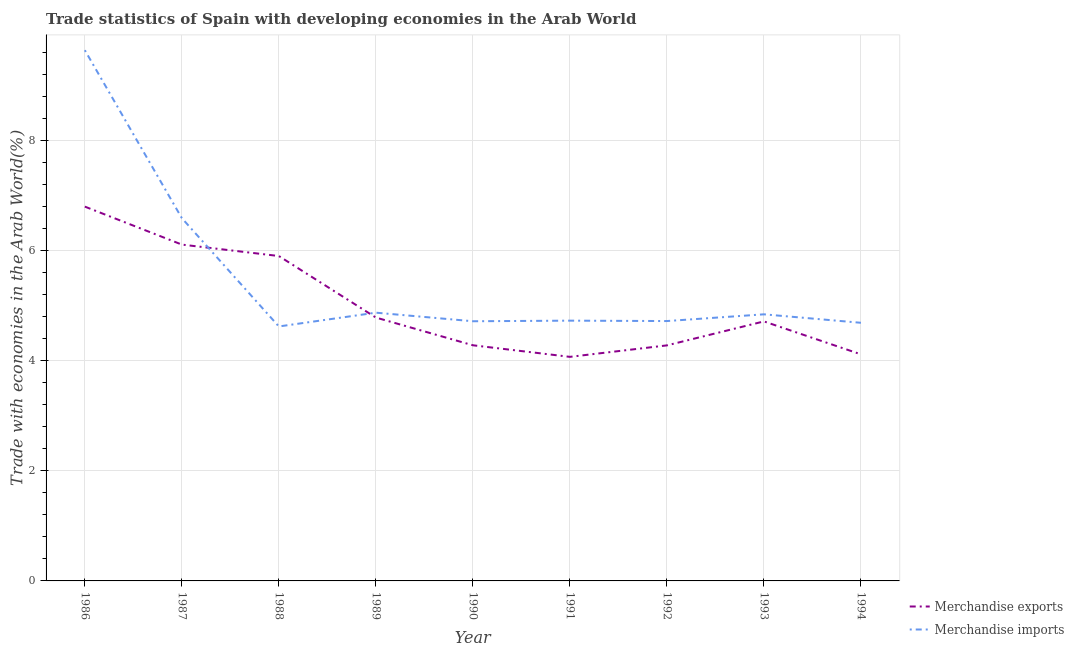How many different coloured lines are there?
Offer a terse response. 2. Does the line corresponding to merchandise exports intersect with the line corresponding to merchandise imports?
Ensure brevity in your answer.  Yes. Is the number of lines equal to the number of legend labels?
Provide a short and direct response. Yes. What is the merchandise imports in 1986?
Your answer should be compact. 9.64. Across all years, what is the maximum merchandise exports?
Offer a very short reply. 6.8. Across all years, what is the minimum merchandise imports?
Provide a succinct answer. 4.62. What is the total merchandise imports in the graph?
Your response must be concise. 49.4. What is the difference between the merchandise exports in 1989 and that in 1992?
Give a very brief answer. 0.51. What is the difference between the merchandise imports in 1993 and the merchandise exports in 1994?
Your answer should be compact. 0.73. What is the average merchandise imports per year?
Make the answer very short. 5.49. In the year 1986, what is the difference between the merchandise imports and merchandise exports?
Offer a very short reply. 2.84. In how many years, is the merchandise exports greater than 2 %?
Your response must be concise. 9. What is the ratio of the merchandise exports in 1988 to that in 1990?
Offer a very short reply. 1.38. Is the merchandise exports in 1992 less than that in 1993?
Offer a terse response. Yes. What is the difference between the highest and the second highest merchandise exports?
Keep it short and to the point. 0.69. What is the difference between the highest and the lowest merchandise imports?
Offer a terse response. 5.02. In how many years, is the merchandise exports greater than the average merchandise exports taken over all years?
Your response must be concise. 3. Is the merchandise imports strictly greater than the merchandise exports over the years?
Your response must be concise. No. Is the merchandise imports strictly less than the merchandise exports over the years?
Provide a short and direct response. No. How many years are there in the graph?
Make the answer very short. 9. Are the values on the major ticks of Y-axis written in scientific E-notation?
Ensure brevity in your answer.  No. Where does the legend appear in the graph?
Keep it short and to the point. Bottom right. What is the title of the graph?
Keep it short and to the point. Trade statistics of Spain with developing economies in the Arab World. What is the label or title of the X-axis?
Your answer should be compact. Year. What is the label or title of the Y-axis?
Provide a short and direct response. Trade with economies in the Arab World(%). What is the Trade with economies in the Arab World(%) of Merchandise exports in 1986?
Your response must be concise. 6.8. What is the Trade with economies in the Arab World(%) of Merchandise imports in 1986?
Your answer should be very brief. 9.64. What is the Trade with economies in the Arab World(%) of Merchandise exports in 1987?
Keep it short and to the point. 6.11. What is the Trade with economies in the Arab World(%) in Merchandise imports in 1987?
Offer a very short reply. 6.59. What is the Trade with economies in the Arab World(%) in Merchandise exports in 1988?
Make the answer very short. 5.9. What is the Trade with economies in the Arab World(%) of Merchandise imports in 1988?
Your answer should be very brief. 4.62. What is the Trade with economies in the Arab World(%) in Merchandise exports in 1989?
Ensure brevity in your answer.  4.78. What is the Trade with economies in the Arab World(%) in Merchandise imports in 1989?
Your response must be concise. 4.87. What is the Trade with economies in the Arab World(%) in Merchandise exports in 1990?
Provide a succinct answer. 4.28. What is the Trade with economies in the Arab World(%) of Merchandise imports in 1990?
Keep it short and to the point. 4.72. What is the Trade with economies in the Arab World(%) of Merchandise exports in 1991?
Offer a terse response. 4.07. What is the Trade with economies in the Arab World(%) in Merchandise imports in 1991?
Offer a very short reply. 4.73. What is the Trade with economies in the Arab World(%) of Merchandise exports in 1992?
Offer a very short reply. 4.28. What is the Trade with economies in the Arab World(%) in Merchandise imports in 1992?
Your response must be concise. 4.72. What is the Trade with economies in the Arab World(%) of Merchandise exports in 1993?
Make the answer very short. 4.71. What is the Trade with economies in the Arab World(%) in Merchandise imports in 1993?
Ensure brevity in your answer.  4.84. What is the Trade with economies in the Arab World(%) of Merchandise exports in 1994?
Offer a terse response. 4.11. What is the Trade with economies in the Arab World(%) in Merchandise imports in 1994?
Offer a very short reply. 4.69. Across all years, what is the maximum Trade with economies in the Arab World(%) of Merchandise exports?
Your answer should be compact. 6.8. Across all years, what is the maximum Trade with economies in the Arab World(%) of Merchandise imports?
Ensure brevity in your answer.  9.64. Across all years, what is the minimum Trade with economies in the Arab World(%) of Merchandise exports?
Make the answer very short. 4.07. Across all years, what is the minimum Trade with economies in the Arab World(%) of Merchandise imports?
Offer a very short reply. 4.62. What is the total Trade with economies in the Arab World(%) in Merchandise exports in the graph?
Keep it short and to the point. 45.04. What is the total Trade with economies in the Arab World(%) of Merchandise imports in the graph?
Offer a terse response. 49.4. What is the difference between the Trade with economies in the Arab World(%) of Merchandise exports in 1986 and that in 1987?
Keep it short and to the point. 0.69. What is the difference between the Trade with economies in the Arab World(%) in Merchandise imports in 1986 and that in 1987?
Offer a very short reply. 3.05. What is the difference between the Trade with economies in the Arab World(%) in Merchandise exports in 1986 and that in 1988?
Your answer should be compact. 0.9. What is the difference between the Trade with economies in the Arab World(%) of Merchandise imports in 1986 and that in 1988?
Ensure brevity in your answer.  5.02. What is the difference between the Trade with economies in the Arab World(%) of Merchandise exports in 1986 and that in 1989?
Give a very brief answer. 2.01. What is the difference between the Trade with economies in the Arab World(%) of Merchandise imports in 1986 and that in 1989?
Offer a terse response. 4.77. What is the difference between the Trade with economies in the Arab World(%) in Merchandise exports in 1986 and that in 1990?
Ensure brevity in your answer.  2.52. What is the difference between the Trade with economies in the Arab World(%) of Merchandise imports in 1986 and that in 1990?
Make the answer very short. 4.92. What is the difference between the Trade with economies in the Arab World(%) in Merchandise exports in 1986 and that in 1991?
Provide a short and direct response. 2.73. What is the difference between the Trade with economies in the Arab World(%) of Merchandise imports in 1986 and that in 1991?
Provide a short and direct response. 4.91. What is the difference between the Trade with economies in the Arab World(%) of Merchandise exports in 1986 and that in 1992?
Your response must be concise. 2.52. What is the difference between the Trade with economies in the Arab World(%) of Merchandise imports in 1986 and that in 1992?
Offer a terse response. 4.92. What is the difference between the Trade with economies in the Arab World(%) of Merchandise exports in 1986 and that in 1993?
Provide a short and direct response. 2.08. What is the difference between the Trade with economies in the Arab World(%) in Merchandise imports in 1986 and that in 1993?
Keep it short and to the point. 4.8. What is the difference between the Trade with economies in the Arab World(%) of Merchandise exports in 1986 and that in 1994?
Make the answer very short. 2.68. What is the difference between the Trade with economies in the Arab World(%) in Merchandise imports in 1986 and that in 1994?
Provide a short and direct response. 4.95. What is the difference between the Trade with economies in the Arab World(%) of Merchandise exports in 1987 and that in 1988?
Your answer should be very brief. 0.21. What is the difference between the Trade with economies in the Arab World(%) in Merchandise imports in 1987 and that in 1988?
Offer a very short reply. 1.97. What is the difference between the Trade with economies in the Arab World(%) of Merchandise exports in 1987 and that in 1989?
Offer a terse response. 1.32. What is the difference between the Trade with economies in the Arab World(%) in Merchandise imports in 1987 and that in 1989?
Offer a terse response. 1.72. What is the difference between the Trade with economies in the Arab World(%) in Merchandise exports in 1987 and that in 1990?
Offer a terse response. 1.83. What is the difference between the Trade with economies in the Arab World(%) in Merchandise imports in 1987 and that in 1990?
Your response must be concise. 1.87. What is the difference between the Trade with economies in the Arab World(%) in Merchandise exports in 1987 and that in 1991?
Ensure brevity in your answer.  2.04. What is the difference between the Trade with economies in the Arab World(%) in Merchandise imports in 1987 and that in 1991?
Your answer should be compact. 1.86. What is the difference between the Trade with economies in the Arab World(%) in Merchandise exports in 1987 and that in 1992?
Provide a succinct answer. 1.83. What is the difference between the Trade with economies in the Arab World(%) in Merchandise imports in 1987 and that in 1992?
Your response must be concise. 1.87. What is the difference between the Trade with economies in the Arab World(%) of Merchandise exports in 1987 and that in 1993?
Keep it short and to the point. 1.39. What is the difference between the Trade with economies in the Arab World(%) in Merchandise imports in 1987 and that in 1993?
Ensure brevity in your answer.  1.75. What is the difference between the Trade with economies in the Arab World(%) in Merchandise exports in 1987 and that in 1994?
Provide a short and direct response. 1.99. What is the difference between the Trade with economies in the Arab World(%) of Merchandise exports in 1988 and that in 1989?
Provide a short and direct response. 1.12. What is the difference between the Trade with economies in the Arab World(%) of Merchandise imports in 1988 and that in 1989?
Your answer should be very brief. -0.25. What is the difference between the Trade with economies in the Arab World(%) in Merchandise exports in 1988 and that in 1990?
Ensure brevity in your answer.  1.62. What is the difference between the Trade with economies in the Arab World(%) in Merchandise imports in 1988 and that in 1990?
Keep it short and to the point. -0.09. What is the difference between the Trade with economies in the Arab World(%) in Merchandise exports in 1988 and that in 1991?
Provide a succinct answer. 1.83. What is the difference between the Trade with economies in the Arab World(%) in Merchandise imports in 1988 and that in 1991?
Give a very brief answer. -0.11. What is the difference between the Trade with economies in the Arab World(%) in Merchandise exports in 1988 and that in 1992?
Provide a short and direct response. 1.62. What is the difference between the Trade with economies in the Arab World(%) of Merchandise imports in 1988 and that in 1992?
Ensure brevity in your answer.  -0.1. What is the difference between the Trade with economies in the Arab World(%) in Merchandise exports in 1988 and that in 1993?
Give a very brief answer. 1.19. What is the difference between the Trade with economies in the Arab World(%) in Merchandise imports in 1988 and that in 1993?
Your response must be concise. -0.22. What is the difference between the Trade with economies in the Arab World(%) of Merchandise exports in 1988 and that in 1994?
Your answer should be compact. 1.79. What is the difference between the Trade with economies in the Arab World(%) in Merchandise imports in 1988 and that in 1994?
Provide a succinct answer. -0.07. What is the difference between the Trade with economies in the Arab World(%) of Merchandise exports in 1989 and that in 1990?
Your answer should be very brief. 0.5. What is the difference between the Trade with economies in the Arab World(%) of Merchandise imports in 1989 and that in 1990?
Provide a succinct answer. 0.16. What is the difference between the Trade with economies in the Arab World(%) of Merchandise exports in 1989 and that in 1991?
Ensure brevity in your answer.  0.71. What is the difference between the Trade with economies in the Arab World(%) in Merchandise imports in 1989 and that in 1991?
Ensure brevity in your answer.  0.14. What is the difference between the Trade with economies in the Arab World(%) of Merchandise exports in 1989 and that in 1992?
Your answer should be compact. 0.51. What is the difference between the Trade with economies in the Arab World(%) of Merchandise imports in 1989 and that in 1992?
Provide a short and direct response. 0.15. What is the difference between the Trade with economies in the Arab World(%) in Merchandise exports in 1989 and that in 1993?
Your answer should be very brief. 0.07. What is the difference between the Trade with economies in the Arab World(%) in Merchandise exports in 1989 and that in 1994?
Offer a very short reply. 0.67. What is the difference between the Trade with economies in the Arab World(%) of Merchandise imports in 1989 and that in 1994?
Your answer should be very brief. 0.18. What is the difference between the Trade with economies in the Arab World(%) of Merchandise exports in 1990 and that in 1991?
Keep it short and to the point. 0.21. What is the difference between the Trade with economies in the Arab World(%) of Merchandise imports in 1990 and that in 1991?
Provide a short and direct response. -0.01. What is the difference between the Trade with economies in the Arab World(%) in Merchandise exports in 1990 and that in 1992?
Provide a short and direct response. 0. What is the difference between the Trade with economies in the Arab World(%) of Merchandise imports in 1990 and that in 1992?
Provide a short and direct response. -0. What is the difference between the Trade with economies in the Arab World(%) of Merchandise exports in 1990 and that in 1993?
Provide a short and direct response. -0.43. What is the difference between the Trade with economies in the Arab World(%) of Merchandise imports in 1990 and that in 1993?
Keep it short and to the point. -0.13. What is the difference between the Trade with economies in the Arab World(%) in Merchandise exports in 1990 and that in 1994?
Give a very brief answer. 0.16. What is the difference between the Trade with economies in the Arab World(%) in Merchandise imports in 1990 and that in 1994?
Your answer should be compact. 0.03. What is the difference between the Trade with economies in the Arab World(%) of Merchandise exports in 1991 and that in 1992?
Offer a very short reply. -0.21. What is the difference between the Trade with economies in the Arab World(%) of Merchandise imports in 1991 and that in 1992?
Provide a short and direct response. 0.01. What is the difference between the Trade with economies in the Arab World(%) of Merchandise exports in 1991 and that in 1993?
Offer a terse response. -0.64. What is the difference between the Trade with economies in the Arab World(%) of Merchandise imports in 1991 and that in 1993?
Provide a short and direct response. -0.11. What is the difference between the Trade with economies in the Arab World(%) in Merchandise exports in 1991 and that in 1994?
Provide a succinct answer. -0.05. What is the difference between the Trade with economies in the Arab World(%) of Merchandise imports in 1991 and that in 1994?
Keep it short and to the point. 0.04. What is the difference between the Trade with economies in the Arab World(%) in Merchandise exports in 1992 and that in 1993?
Provide a short and direct response. -0.44. What is the difference between the Trade with economies in the Arab World(%) of Merchandise imports in 1992 and that in 1993?
Offer a very short reply. -0.12. What is the difference between the Trade with economies in the Arab World(%) of Merchandise exports in 1992 and that in 1994?
Keep it short and to the point. 0.16. What is the difference between the Trade with economies in the Arab World(%) in Merchandise imports in 1992 and that in 1994?
Provide a succinct answer. 0.03. What is the difference between the Trade with economies in the Arab World(%) in Merchandise exports in 1993 and that in 1994?
Offer a terse response. 0.6. What is the difference between the Trade with economies in the Arab World(%) in Merchandise imports in 1993 and that in 1994?
Provide a succinct answer. 0.15. What is the difference between the Trade with economies in the Arab World(%) of Merchandise exports in 1986 and the Trade with economies in the Arab World(%) of Merchandise imports in 1987?
Offer a terse response. 0.21. What is the difference between the Trade with economies in the Arab World(%) of Merchandise exports in 1986 and the Trade with economies in the Arab World(%) of Merchandise imports in 1988?
Keep it short and to the point. 2.18. What is the difference between the Trade with economies in the Arab World(%) of Merchandise exports in 1986 and the Trade with economies in the Arab World(%) of Merchandise imports in 1989?
Make the answer very short. 1.93. What is the difference between the Trade with economies in the Arab World(%) in Merchandise exports in 1986 and the Trade with economies in the Arab World(%) in Merchandise imports in 1990?
Give a very brief answer. 2.08. What is the difference between the Trade with economies in the Arab World(%) of Merchandise exports in 1986 and the Trade with economies in the Arab World(%) of Merchandise imports in 1991?
Ensure brevity in your answer.  2.07. What is the difference between the Trade with economies in the Arab World(%) in Merchandise exports in 1986 and the Trade with economies in the Arab World(%) in Merchandise imports in 1992?
Provide a succinct answer. 2.08. What is the difference between the Trade with economies in the Arab World(%) of Merchandise exports in 1986 and the Trade with economies in the Arab World(%) of Merchandise imports in 1993?
Make the answer very short. 1.96. What is the difference between the Trade with economies in the Arab World(%) in Merchandise exports in 1986 and the Trade with economies in the Arab World(%) in Merchandise imports in 1994?
Provide a succinct answer. 2.11. What is the difference between the Trade with economies in the Arab World(%) in Merchandise exports in 1987 and the Trade with economies in the Arab World(%) in Merchandise imports in 1988?
Your answer should be very brief. 1.49. What is the difference between the Trade with economies in the Arab World(%) in Merchandise exports in 1987 and the Trade with economies in the Arab World(%) in Merchandise imports in 1989?
Provide a short and direct response. 1.24. What is the difference between the Trade with economies in the Arab World(%) of Merchandise exports in 1987 and the Trade with economies in the Arab World(%) of Merchandise imports in 1990?
Your answer should be very brief. 1.39. What is the difference between the Trade with economies in the Arab World(%) of Merchandise exports in 1987 and the Trade with economies in the Arab World(%) of Merchandise imports in 1991?
Offer a terse response. 1.38. What is the difference between the Trade with economies in the Arab World(%) of Merchandise exports in 1987 and the Trade with economies in the Arab World(%) of Merchandise imports in 1992?
Your answer should be compact. 1.39. What is the difference between the Trade with economies in the Arab World(%) of Merchandise exports in 1987 and the Trade with economies in the Arab World(%) of Merchandise imports in 1993?
Provide a short and direct response. 1.27. What is the difference between the Trade with economies in the Arab World(%) of Merchandise exports in 1987 and the Trade with economies in the Arab World(%) of Merchandise imports in 1994?
Offer a terse response. 1.42. What is the difference between the Trade with economies in the Arab World(%) in Merchandise exports in 1988 and the Trade with economies in the Arab World(%) in Merchandise imports in 1989?
Make the answer very short. 1.03. What is the difference between the Trade with economies in the Arab World(%) in Merchandise exports in 1988 and the Trade with economies in the Arab World(%) in Merchandise imports in 1990?
Provide a short and direct response. 1.18. What is the difference between the Trade with economies in the Arab World(%) in Merchandise exports in 1988 and the Trade with economies in the Arab World(%) in Merchandise imports in 1991?
Provide a short and direct response. 1.17. What is the difference between the Trade with economies in the Arab World(%) of Merchandise exports in 1988 and the Trade with economies in the Arab World(%) of Merchandise imports in 1992?
Give a very brief answer. 1.18. What is the difference between the Trade with economies in the Arab World(%) in Merchandise exports in 1988 and the Trade with economies in the Arab World(%) in Merchandise imports in 1993?
Keep it short and to the point. 1.06. What is the difference between the Trade with economies in the Arab World(%) in Merchandise exports in 1988 and the Trade with economies in the Arab World(%) in Merchandise imports in 1994?
Offer a very short reply. 1.21. What is the difference between the Trade with economies in the Arab World(%) in Merchandise exports in 1989 and the Trade with economies in the Arab World(%) in Merchandise imports in 1990?
Your answer should be very brief. 0.07. What is the difference between the Trade with economies in the Arab World(%) of Merchandise exports in 1989 and the Trade with economies in the Arab World(%) of Merchandise imports in 1991?
Keep it short and to the point. 0.06. What is the difference between the Trade with economies in the Arab World(%) of Merchandise exports in 1989 and the Trade with economies in the Arab World(%) of Merchandise imports in 1992?
Ensure brevity in your answer.  0.06. What is the difference between the Trade with economies in the Arab World(%) in Merchandise exports in 1989 and the Trade with economies in the Arab World(%) in Merchandise imports in 1993?
Make the answer very short. -0.06. What is the difference between the Trade with economies in the Arab World(%) of Merchandise exports in 1989 and the Trade with economies in the Arab World(%) of Merchandise imports in 1994?
Offer a very short reply. 0.1. What is the difference between the Trade with economies in the Arab World(%) of Merchandise exports in 1990 and the Trade with economies in the Arab World(%) of Merchandise imports in 1991?
Provide a short and direct response. -0.45. What is the difference between the Trade with economies in the Arab World(%) in Merchandise exports in 1990 and the Trade with economies in the Arab World(%) in Merchandise imports in 1992?
Give a very brief answer. -0.44. What is the difference between the Trade with economies in the Arab World(%) in Merchandise exports in 1990 and the Trade with economies in the Arab World(%) in Merchandise imports in 1993?
Ensure brevity in your answer.  -0.56. What is the difference between the Trade with economies in the Arab World(%) of Merchandise exports in 1990 and the Trade with economies in the Arab World(%) of Merchandise imports in 1994?
Offer a terse response. -0.41. What is the difference between the Trade with economies in the Arab World(%) of Merchandise exports in 1991 and the Trade with economies in the Arab World(%) of Merchandise imports in 1992?
Ensure brevity in your answer.  -0.65. What is the difference between the Trade with economies in the Arab World(%) in Merchandise exports in 1991 and the Trade with economies in the Arab World(%) in Merchandise imports in 1993?
Ensure brevity in your answer.  -0.77. What is the difference between the Trade with economies in the Arab World(%) of Merchandise exports in 1991 and the Trade with economies in the Arab World(%) of Merchandise imports in 1994?
Make the answer very short. -0.62. What is the difference between the Trade with economies in the Arab World(%) of Merchandise exports in 1992 and the Trade with economies in the Arab World(%) of Merchandise imports in 1993?
Give a very brief answer. -0.56. What is the difference between the Trade with economies in the Arab World(%) in Merchandise exports in 1992 and the Trade with economies in the Arab World(%) in Merchandise imports in 1994?
Keep it short and to the point. -0.41. What is the difference between the Trade with economies in the Arab World(%) in Merchandise exports in 1993 and the Trade with economies in the Arab World(%) in Merchandise imports in 1994?
Make the answer very short. 0.03. What is the average Trade with economies in the Arab World(%) of Merchandise exports per year?
Offer a terse response. 5. What is the average Trade with economies in the Arab World(%) in Merchandise imports per year?
Keep it short and to the point. 5.49. In the year 1986, what is the difference between the Trade with economies in the Arab World(%) in Merchandise exports and Trade with economies in the Arab World(%) in Merchandise imports?
Make the answer very short. -2.84. In the year 1987, what is the difference between the Trade with economies in the Arab World(%) of Merchandise exports and Trade with economies in the Arab World(%) of Merchandise imports?
Provide a succinct answer. -0.48. In the year 1988, what is the difference between the Trade with economies in the Arab World(%) in Merchandise exports and Trade with economies in the Arab World(%) in Merchandise imports?
Keep it short and to the point. 1.28. In the year 1989, what is the difference between the Trade with economies in the Arab World(%) in Merchandise exports and Trade with economies in the Arab World(%) in Merchandise imports?
Keep it short and to the point. -0.09. In the year 1990, what is the difference between the Trade with economies in the Arab World(%) of Merchandise exports and Trade with economies in the Arab World(%) of Merchandise imports?
Make the answer very short. -0.44. In the year 1991, what is the difference between the Trade with economies in the Arab World(%) of Merchandise exports and Trade with economies in the Arab World(%) of Merchandise imports?
Provide a short and direct response. -0.66. In the year 1992, what is the difference between the Trade with economies in the Arab World(%) of Merchandise exports and Trade with economies in the Arab World(%) of Merchandise imports?
Offer a terse response. -0.44. In the year 1993, what is the difference between the Trade with economies in the Arab World(%) of Merchandise exports and Trade with economies in the Arab World(%) of Merchandise imports?
Give a very brief answer. -0.13. In the year 1994, what is the difference between the Trade with economies in the Arab World(%) of Merchandise exports and Trade with economies in the Arab World(%) of Merchandise imports?
Provide a succinct answer. -0.57. What is the ratio of the Trade with economies in the Arab World(%) in Merchandise exports in 1986 to that in 1987?
Make the answer very short. 1.11. What is the ratio of the Trade with economies in the Arab World(%) in Merchandise imports in 1986 to that in 1987?
Your response must be concise. 1.46. What is the ratio of the Trade with economies in the Arab World(%) in Merchandise exports in 1986 to that in 1988?
Provide a succinct answer. 1.15. What is the ratio of the Trade with economies in the Arab World(%) in Merchandise imports in 1986 to that in 1988?
Your answer should be very brief. 2.09. What is the ratio of the Trade with economies in the Arab World(%) of Merchandise exports in 1986 to that in 1989?
Provide a short and direct response. 1.42. What is the ratio of the Trade with economies in the Arab World(%) in Merchandise imports in 1986 to that in 1989?
Your answer should be compact. 1.98. What is the ratio of the Trade with economies in the Arab World(%) in Merchandise exports in 1986 to that in 1990?
Offer a very short reply. 1.59. What is the ratio of the Trade with economies in the Arab World(%) of Merchandise imports in 1986 to that in 1990?
Provide a short and direct response. 2.04. What is the ratio of the Trade with economies in the Arab World(%) of Merchandise exports in 1986 to that in 1991?
Offer a very short reply. 1.67. What is the ratio of the Trade with economies in the Arab World(%) of Merchandise imports in 1986 to that in 1991?
Offer a terse response. 2.04. What is the ratio of the Trade with economies in the Arab World(%) in Merchandise exports in 1986 to that in 1992?
Ensure brevity in your answer.  1.59. What is the ratio of the Trade with economies in the Arab World(%) in Merchandise imports in 1986 to that in 1992?
Offer a very short reply. 2.04. What is the ratio of the Trade with economies in the Arab World(%) in Merchandise exports in 1986 to that in 1993?
Provide a succinct answer. 1.44. What is the ratio of the Trade with economies in the Arab World(%) in Merchandise imports in 1986 to that in 1993?
Your answer should be very brief. 1.99. What is the ratio of the Trade with economies in the Arab World(%) of Merchandise exports in 1986 to that in 1994?
Give a very brief answer. 1.65. What is the ratio of the Trade with economies in the Arab World(%) in Merchandise imports in 1986 to that in 1994?
Your answer should be very brief. 2.06. What is the ratio of the Trade with economies in the Arab World(%) of Merchandise exports in 1987 to that in 1988?
Make the answer very short. 1.04. What is the ratio of the Trade with economies in the Arab World(%) in Merchandise imports in 1987 to that in 1988?
Ensure brevity in your answer.  1.43. What is the ratio of the Trade with economies in the Arab World(%) of Merchandise exports in 1987 to that in 1989?
Your answer should be compact. 1.28. What is the ratio of the Trade with economies in the Arab World(%) in Merchandise imports in 1987 to that in 1989?
Offer a very short reply. 1.35. What is the ratio of the Trade with economies in the Arab World(%) in Merchandise exports in 1987 to that in 1990?
Offer a terse response. 1.43. What is the ratio of the Trade with economies in the Arab World(%) in Merchandise imports in 1987 to that in 1990?
Make the answer very short. 1.4. What is the ratio of the Trade with economies in the Arab World(%) of Merchandise exports in 1987 to that in 1991?
Provide a short and direct response. 1.5. What is the ratio of the Trade with economies in the Arab World(%) in Merchandise imports in 1987 to that in 1991?
Keep it short and to the point. 1.39. What is the ratio of the Trade with economies in the Arab World(%) in Merchandise exports in 1987 to that in 1992?
Offer a terse response. 1.43. What is the ratio of the Trade with economies in the Arab World(%) in Merchandise imports in 1987 to that in 1992?
Give a very brief answer. 1.4. What is the ratio of the Trade with economies in the Arab World(%) of Merchandise exports in 1987 to that in 1993?
Your response must be concise. 1.3. What is the ratio of the Trade with economies in the Arab World(%) of Merchandise imports in 1987 to that in 1993?
Your response must be concise. 1.36. What is the ratio of the Trade with economies in the Arab World(%) of Merchandise exports in 1987 to that in 1994?
Your answer should be compact. 1.48. What is the ratio of the Trade with economies in the Arab World(%) of Merchandise imports in 1987 to that in 1994?
Ensure brevity in your answer.  1.41. What is the ratio of the Trade with economies in the Arab World(%) of Merchandise exports in 1988 to that in 1989?
Offer a very short reply. 1.23. What is the ratio of the Trade with economies in the Arab World(%) of Merchandise imports in 1988 to that in 1989?
Provide a short and direct response. 0.95. What is the ratio of the Trade with economies in the Arab World(%) of Merchandise exports in 1988 to that in 1990?
Your answer should be compact. 1.38. What is the ratio of the Trade with economies in the Arab World(%) in Merchandise imports in 1988 to that in 1990?
Give a very brief answer. 0.98. What is the ratio of the Trade with economies in the Arab World(%) in Merchandise exports in 1988 to that in 1991?
Provide a succinct answer. 1.45. What is the ratio of the Trade with economies in the Arab World(%) of Merchandise imports in 1988 to that in 1991?
Make the answer very short. 0.98. What is the ratio of the Trade with economies in the Arab World(%) of Merchandise exports in 1988 to that in 1992?
Your answer should be very brief. 1.38. What is the ratio of the Trade with economies in the Arab World(%) in Merchandise imports in 1988 to that in 1992?
Offer a very short reply. 0.98. What is the ratio of the Trade with economies in the Arab World(%) of Merchandise exports in 1988 to that in 1993?
Ensure brevity in your answer.  1.25. What is the ratio of the Trade with economies in the Arab World(%) of Merchandise imports in 1988 to that in 1993?
Ensure brevity in your answer.  0.95. What is the ratio of the Trade with economies in the Arab World(%) in Merchandise exports in 1988 to that in 1994?
Offer a very short reply. 1.43. What is the ratio of the Trade with economies in the Arab World(%) in Merchandise imports in 1988 to that in 1994?
Provide a succinct answer. 0.99. What is the ratio of the Trade with economies in the Arab World(%) in Merchandise exports in 1989 to that in 1990?
Your answer should be very brief. 1.12. What is the ratio of the Trade with economies in the Arab World(%) of Merchandise imports in 1989 to that in 1990?
Keep it short and to the point. 1.03. What is the ratio of the Trade with economies in the Arab World(%) of Merchandise exports in 1989 to that in 1991?
Make the answer very short. 1.18. What is the ratio of the Trade with economies in the Arab World(%) of Merchandise imports in 1989 to that in 1991?
Your response must be concise. 1.03. What is the ratio of the Trade with economies in the Arab World(%) in Merchandise exports in 1989 to that in 1992?
Provide a succinct answer. 1.12. What is the ratio of the Trade with economies in the Arab World(%) in Merchandise imports in 1989 to that in 1992?
Your answer should be very brief. 1.03. What is the ratio of the Trade with economies in the Arab World(%) in Merchandise exports in 1989 to that in 1993?
Provide a succinct answer. 1.01. What is the ratio of the Trade with economies in the Arab World(%) in Merchandise exports in 1989 to that in 1994?
Ensure brevity in your answer.  1.16. What is the ratio of the Trade with economies in the Arab World(%) of Merchandise imports in 1989 to that in 1994?
Offer a very short reply. 1.04. What is the ratio of the Trade with economies in the Arab World(%) in Merchandise exports in 1990 to that in 1991?
Your answer should be compact. 1.05. What is the ratio of the Trade with economies in the Arab World(%) in Merchandise imports in 1990 to that in 1991?
Give a very brief answer. 1. What is the ratio of the Trade with economies in the Arab World(%) of Merchandise imports in 1990 to that in 1992?
Give a very brief answer. 1. What is the ratio of the Trade with economies in the Arab World(%) in Merchandise exports in 1990 to that in 1993?
Give a very brief answer. 0.91. What is the ratio of the Trade with economies in the Arab World(%) in Merchandise exports in 1990 to that in 1994?
Your answer should be compact. 1.04. What is the ratio of the Trade with economies in the Arab World(%) in Merchandise imports in 1990 to that in 1994?
Provide a succinct answer. 1.01. What is the ratio of the Trade with economies in the Arab World(%) of Merchandise exports in 1991 to that in 1992?
Provide a short and direct response. 0.95. What is the ratio of the Trade with economies in the Arab World(%) of Merchandise imports in 1991 to that in 1992?
Offer a very short reply. 1. What is the ratio of the Trade with economies in the Arab World(%) in Merchandise exports in 1991 to that in 1993?
Your answer should be compact. 0.86. What is the ratio of the Trade with economies in the Arab World(%) in Merchandise imports in 1991 to that in 1993?
Offer a very short reply. 0.98. What is the ratio of the Trade with economies in the Arab World(%) in Merchandise exports in 1991 to that in 1994?
Keep it short and to the point. 0.99. What is the ratio of the Trade with economies in the Arab World(%) in Merchandise imports in 1991 to that in 1994?
Your response must be concise. 1.01. What is the ratio of the Trade with economies in the Arab World(%) in Merchandise exports in 1992 to that in 1993?
Keep it short and to the point. 0.91. What is the ratio of the Trade with economies in the Arab World(%) in Merchandise imports in 1992 to that in 1993?
Keep it short and to the point. 0.97. What is the ratio of the Trade with economies in the Arab World(%) of Merchandise exports in 1992 to that in 1994?
Offer a very short reply. 1.04. What is the ratio of the Trade with economies in the Arab World(%) in Merchandise exports in 1993 to that in 1994?
Ensure brevity in your answer.  1.15. What is the ratio of the Trade with economies in the Arab World(%) in Merchandise imports in 1993 to that in 1994?
Your response must be concise. 1.03. What is the difference between the highest and the second highest Trade with economies in the Arab World(%) of Merchandise exports?
Provide a short and direct response. 0.69. What is the difference between the highest and the second highest Trade with economies in the Arab World(%) in Merchandise imports?
Ensure brevity in your answer.  3.05. What is the difference between the highest and the lowest Trade with economies in the Arab World(%) of Merchandise exports?
Your response must be concise. 2.73. What is the difference between the highest and the lowest Trade with economies in the Arab World(%) of Merchandise imports?
Give a very brief answer. 5.02. 